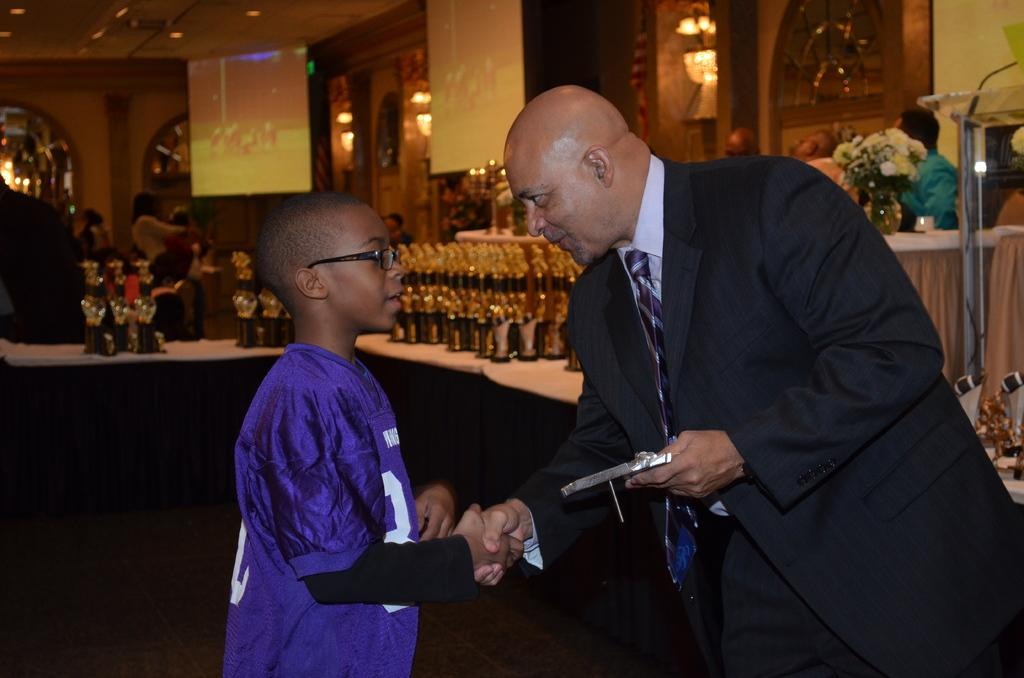What is happening between the person and the child in the image? The person is giving a hand to the child in the image. What can be seen on the right side of the image? There is a flower bouquet on the right side of the image. What objects are visible in the background of the image? There are bottles visible in the background of the image. What type of noise can be heard coming from the person in the image? There is no indication of any noise in the image, so it cannot be determined from the image. 